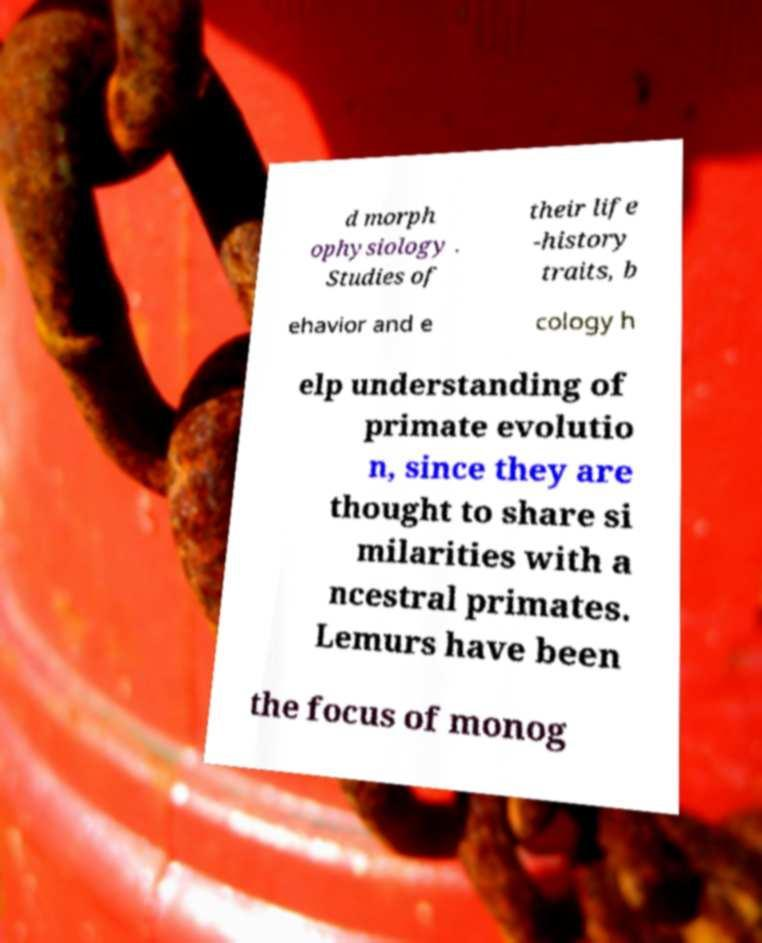Could you assist in decoding the text presented in this image and type it out clearly? d morph ophysiology . Studies of their life -history traits, b ehavior and e cology h elp understanding of primate evolutio n, since they are thought to share si milarities with a ncestral primates. Lemurs have been the focus of monog 